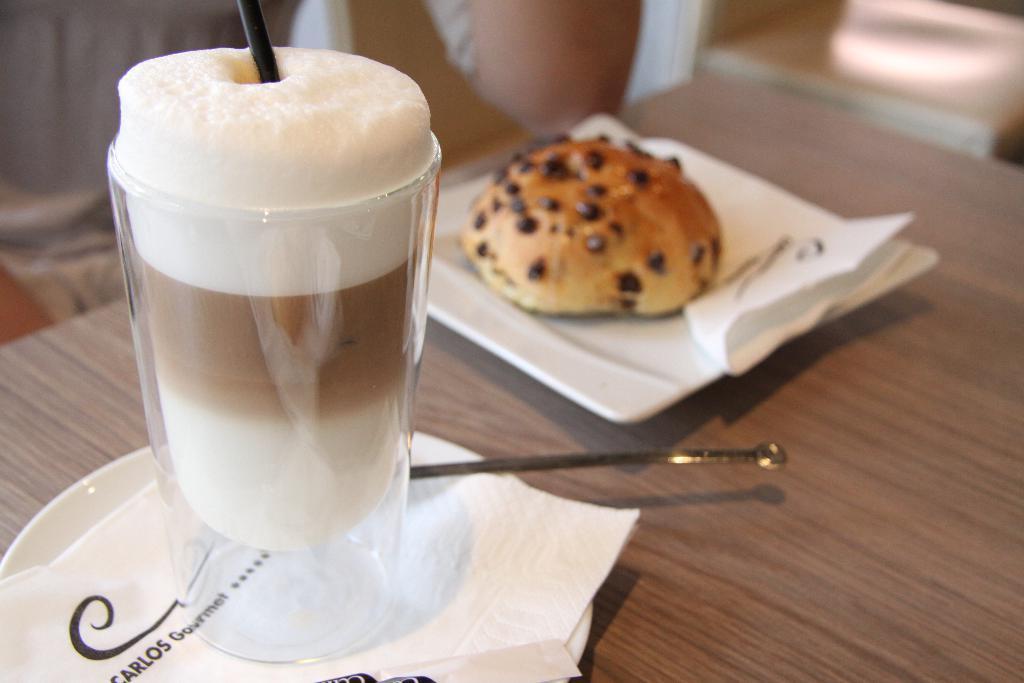Please provide a concise description of this image. At the bottom of the image there is a table, on the table there is a saucer, paper, glass, plate and bun. Behind the table a person is sitting. In the top right corner of the image there is a chair. 